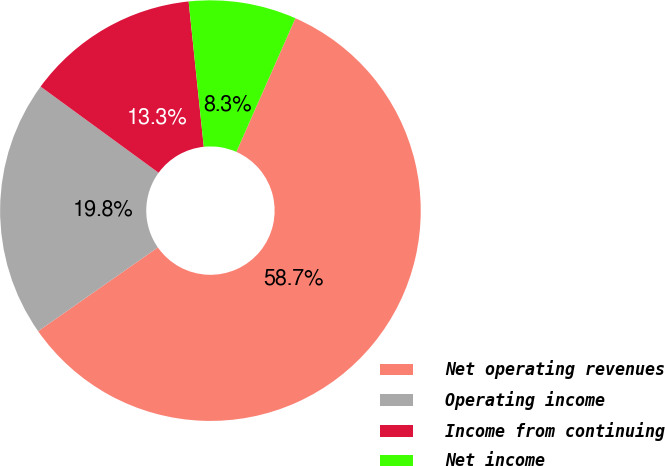Convert chart to OTSL. <chart><loc_0><loc_0><loc_500><loc_500><pie_chart><fcel>Net operating revenues<fcel>Operating income<fcel>Income from continuing<fcel>Net income<nl><fcel>58.67%<fcel>19.76%<fcel>13.31%<fcel>8.27%<nl></chart> 